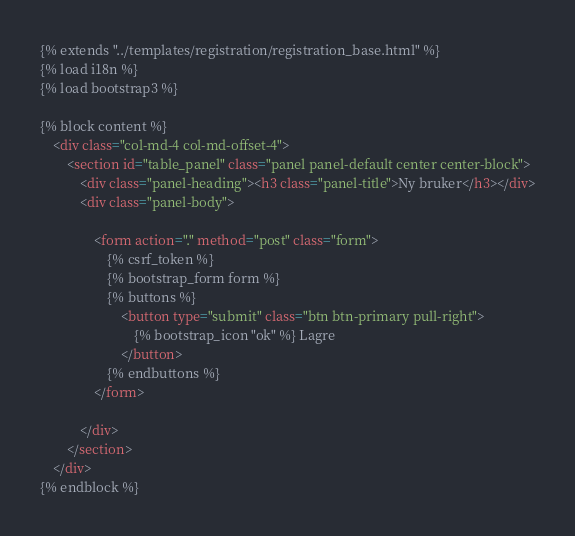Convert code to text. <code><loc_0><loc_0><loc_500><loc_500><_HTML_>{% extends "../templates/registration/registration_base.html" %}
{% load i18n %}
{% load bootstrap3 %}

{% block content %}
    <div class="col-md-4 col-md-offset-4">
        <section id="table_panel" class="panel panel-default center center-block">
            <div class="panel-heading"><h3 class="panel-title">Ny bruker</h3></div>
            <div class="panel-body">

                <form action="." method="post" class="form">
                    {% csrf_token %}
                    {% bootstrap_form form %}
                    {% buttons %}
                        <button type="submit" class="btn btn-primary pull-right">
                            {% bootstrap_icon "ok" %} Lagre
                        </button>
                    {% endbuttons %}
                </form>

            </div>
        </section>
    </div>
{% endblock %}</code> 